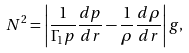<formula> <loc_0><loc_0><loc_500><loc_500>N ^ { 2 } = \left | \frac { 1 } { \Gamma _ { 1 } p } \frac { d p } { d r } - \frac { 1 } { \rho } \frac { d \rho } { d r } \right | g ,</formula> 